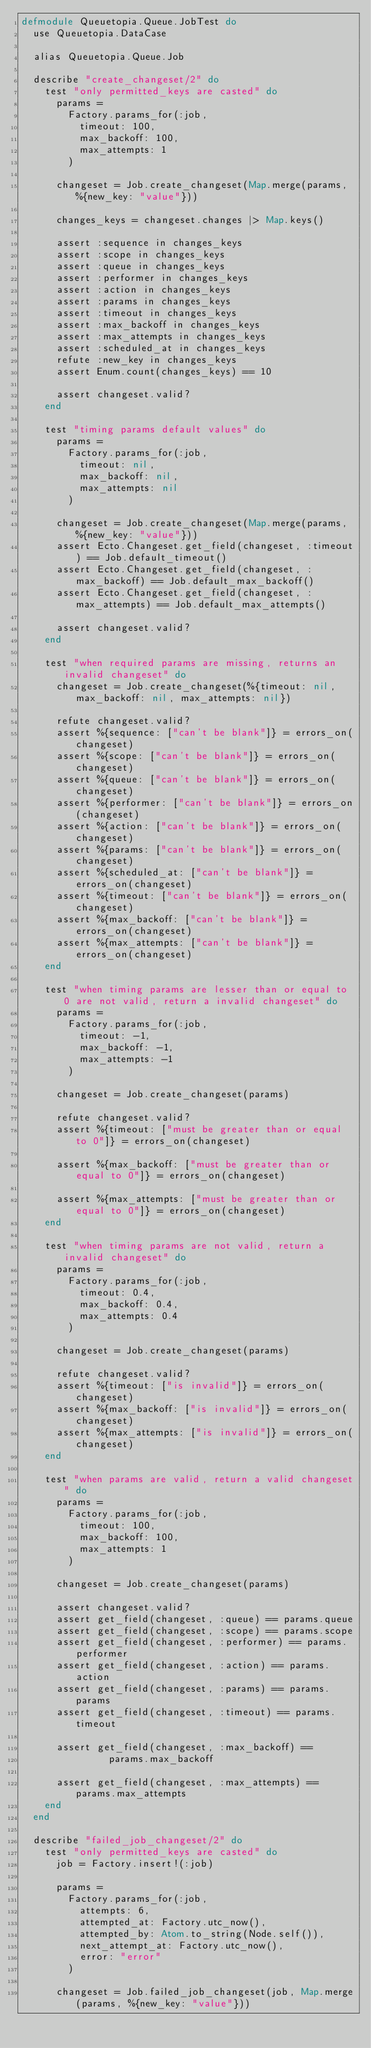<code> <loc_0><loc_0><loc_500><loc_500><_Elixir_>defmodule Queuetopia.Queue.JobTest do
  use Queuetopia.DataCase

  alias Queuetopia.Queue.Job

  describe "create_changeset/2" do
    test "only permitted_keys are casted" do
      params =
        Factory.params_for(:job,
          timeout: 100,
          max_backoff: 100,
          max_attempts: 1
        )

      changeset = Job.create_changeset(Map.merge(params, %{new_key: "value"}))

      changes_keys = changeset.changes |> Map.keys()

      assert :sequence in changes_keys
      assert :scope in changes_keys
      assert :queue in changes_keys
      assert :performer in changes_keys
      assert :action in changes_keys
      assert :params in changes_keys
      assert :timeout in changes_keys
      assert :max_backoff in changes_keys
      assert :max_attempts in changes_keys
      assert :scheduled_at in changes_keys
      refute :new_key in changes_keys
      assert Enum.count(changes_keys) == 10

      assert changeset.valid?
    end

    test "timing params default values" do
      params =
        Factory.params_for(:job,
          timeout: nil,
          max_backoff: nil,
          max_attempts: nil
        )

      changeset = Job.create_changeset(Map.merge(params, %{new_key: "value"}))
      assert Ecto.Changeset.get_field(changeset, :timeout) == Job.default_timeout()
      assert Ecto.Changeset.get_field(changeset, :max_backoff) == Job.default_max_backoff()
      assert Ecto.Changeset.get_field(changeset, :max_attempts) == Job.default_max_attempts()

      assert changeset.valid?
    end

    test "when required params are missing, returns an invalid changeset" do
      changeset = Job.create_changeset(%{timeout: nil, max_backoff: nil, max_attempts: nil})

      refute changeset.valid?
      assert %{sequence: ["can't be blank"]} = errors_on(changeset)
      assert %{scope: ["can't be blank"]} = errors_on(changeset)
      assert %{queue: ["can't be blank"]} = errors_on(changeset)
      assert %{performer: ["can't be blank"]} = errors_on(changeset)
      assert %{action: ["can't be blank"]} = errors_on(changeset)
      assert %{params: ["can't be blank"]} = errors_on(changeset)
      assert %{scheduled_at: ["can't be blank"]} = errors_on(changeset)
      assert %{timeout: ["can't be blank"]} = errors_on(changeset)
      assert %{max_backoff: ["can't be blank"]} = errors_on(changeset)
      assert %{max_attempts: ["can't be blank"]} = errors_on(changeset)
    end

    test "when timing params are lesser than or equal to 0 are not valid, return a invalid changeset" do
      params =
        Factory.params_for(:job,
          timeout: -1,
          max_backoff: -1,
          max_attempts: -1
        )

      changeset = Job.create_changeset(params)

      refute changeset.valid?
      assert %{timeout: ["must be greater than or equal to 0"]} = errors_on(changeset)

      assert %{max_backoff: ["must be greater than or equal to 0"]} = errors_on(changeset)

      assert %{max_attempts: ["must be greater than or equal to 0"]} = errors_on(changeset)
    end

    test "when timing params are not valid, return a invalid changeset" do
      params =
        Factory.params_for(:job,
          timeout: 0.4,
          max_backoff: 0.4,
          max_attempts: 0.4
        )

      changeset = Job.create_changeset(params)

      refute changeset.valid?
      assert %{timeout: ["is invalid"]} = errors_on(changeset)
      assert %{max_backoff: ["is invalid"]} = errors_on(changeset)
      assert %{max_attempts: ["is invalid"]} = errors_on(changeset)
    end

    test "when params are valid, return a valid changeset" do
      params =
        Factory.params_for(:job,
          timeout: 100,
          max_backoff: 100,
          max_attempts: 1
        )

      changeset = Job.create_changeset(params)

      assert changeset.valid?
      assert get_field(changeset, :queue) == params.queue
      assert get_field(changeset, :scope) == params.scope
      assert get_field(changeset, :performer) == params.performer
      assert get_field(changeset, :action) == params.action
      assert get_field(changeset, :params) == params.params
      assert get_field(changeset, :timeout) == params.timeout

      assert get_field(changeset, :max_backoff) ==
               params.max_backoff

      assert get_field(changeset, :max_attempts) == params.max_attempts
    end
  end

  describe "failed_job_changeset/2" do
    test "only permitted_keys are casted" do
      job = Factory.insert!(:job)

      params =
        Factory.params_for(:job,
          attempts: 6,
          attempted_at: Factory.utc_now(),
          attempted_by: Atom.to_string(Node.self()),
          next_attempt_at: Factory.utc_now(),
          error: "error"
        )

      changeset = Job.failed_job_changeset(job, Map.merge(params, %{new_key: "value"}))</code> 